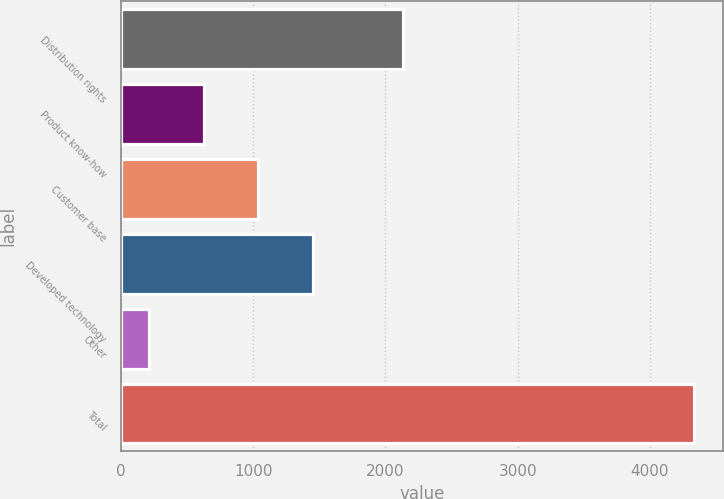Convert chart to OTSL. <chart><loc_0><loc_0><loc_500><loc_500><bar_chart><fcel>Distribution rights<fcel>Product know-how<fcel>Customer base<fcel>Developed technology<fcel>Other<fcel>Total<nl><fcel>2132<fcel>626.1<fcel>1038.2<fcel>1450.3<fcel>214<fcel>4335<nl></chart> 